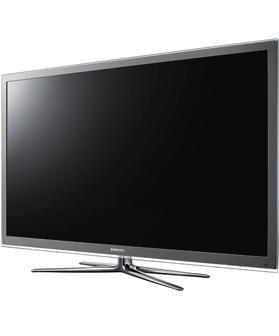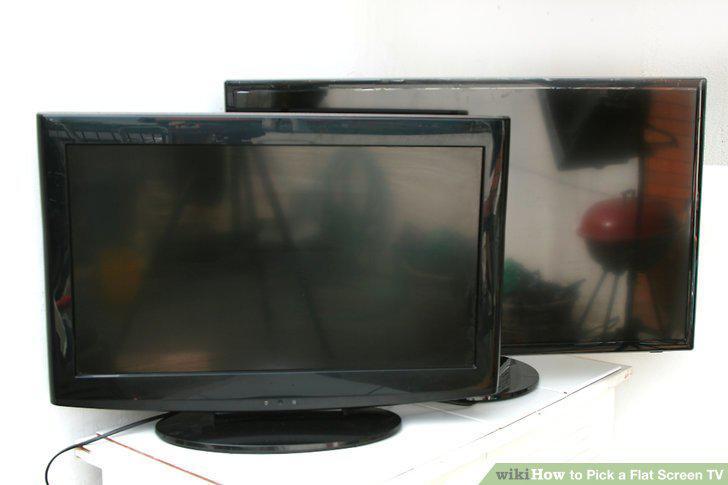The first image is the image on the left, the second image is the image on the right. Evaluate the accuracy of this statement regarding the images: "The left and right image contains the same number of computer monitors with one being silver.". Is it true? Answer yes or no. No. 